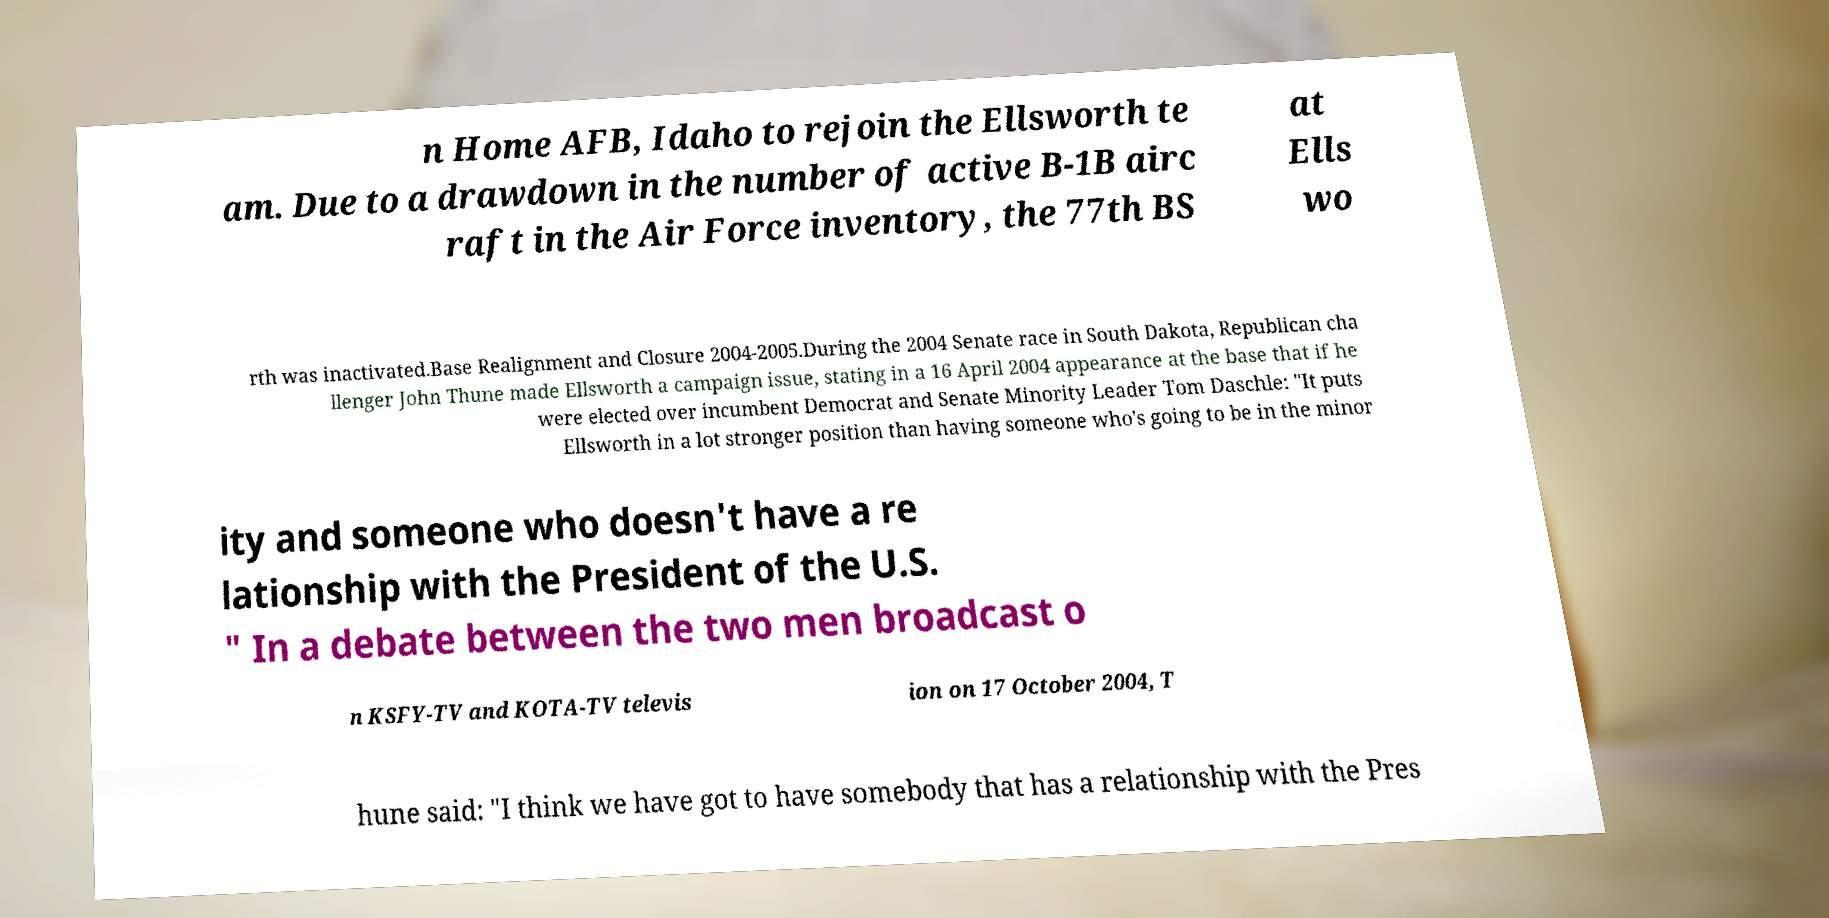For documentation purposes, I need the text within this image transcribed. Could you provide that? n Home AFB, Idaho to rejoin the Ellsworth te am. Due to a drawdown in the number of active B-1B airc raft in the Air Force inventory, the 77th BS at Ells wo rth was inactivated.Base Realignment and Closure 2004-2005.During the 2004 Senate race in South Dakota, Republican cha llenger John Thune made Ellsworth a campaign issue, stating in a 16 April 2004 appearance at the base that if he were elected over incumbent Democrat and Senate Minority Leader Tom Daschle: "It puts Ellsworth in a lot stronger position than having someone who's going to be in the minor ity and someone who doesn't have a re lationship with the President of the U.S. " In a debate between the two men broadcast o n KSFY-TV and KOTA-TV televis ion on 17 October 2004, T hune said: "I think we have got to have somebody that has a relationship with the Pres 